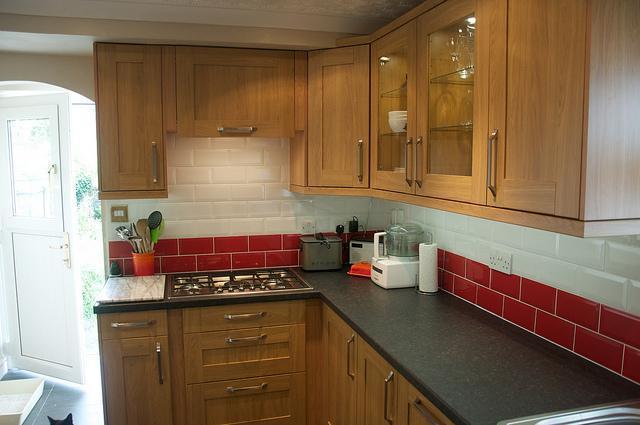How many glass cabinets are there?
Give a very brief answer. 2. How many rows of brick are red?
Give a very brief answer. 2. How many people are wearing a tie in the picture?
Give a very brief answer. 0. 